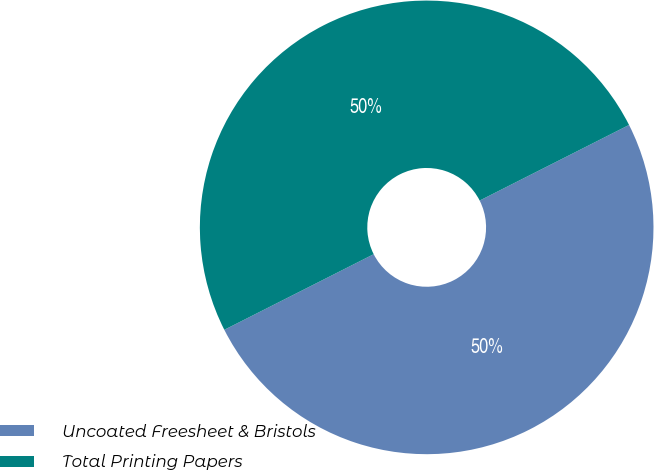Convert chart. <chart><loc_0><loc_0><loc_500><loc_500><pie_chart><fcel>Uncoated Freesheet & Bristols<fcel>Total Printing Papers<nl><fcel>50.0%<fcel>50.0%<nl></chart> 